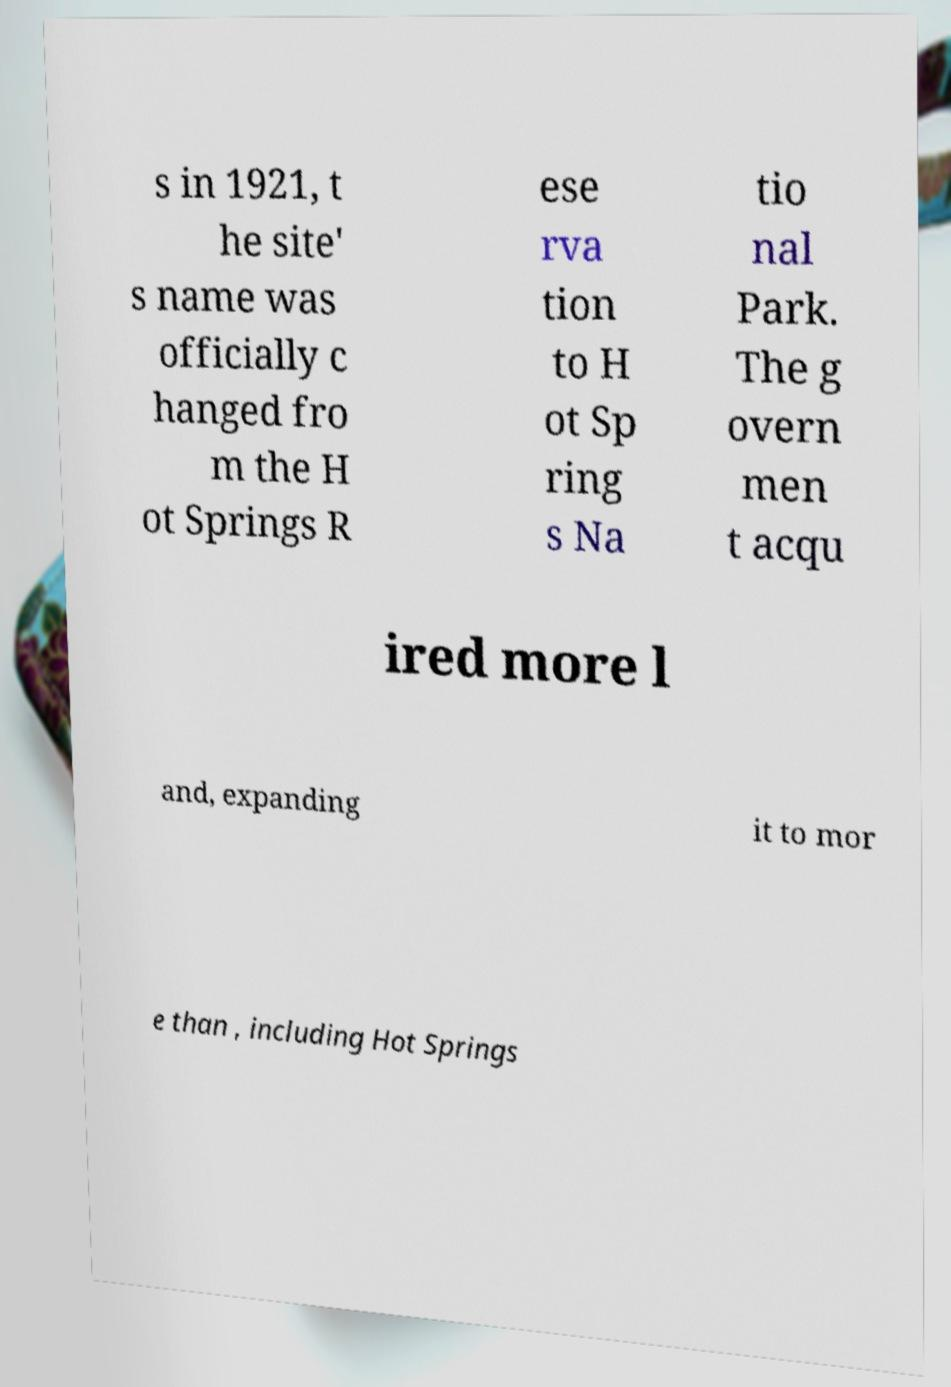Please identify and transcribe the text found in this image. s in 1921, t he site' s name was officially c hanged fro m the H ot Springs R ese rva tion to H ot Sp ring s Na tio nal Park. The g overn men t acqu ired more l and, expanding it to mor e than , including Hot Springs 